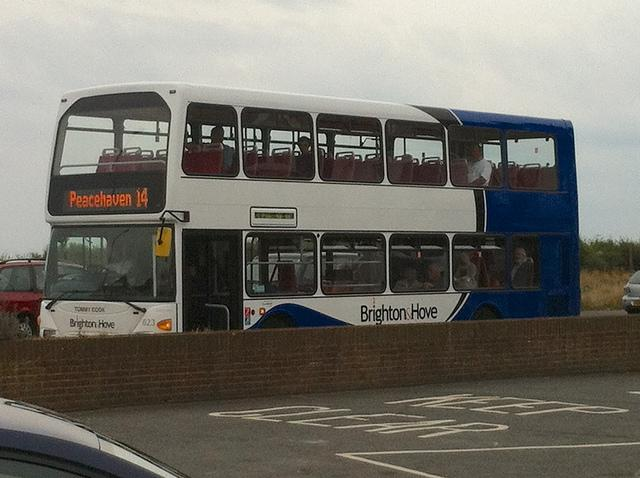In which country's streets does this bus travel? england 